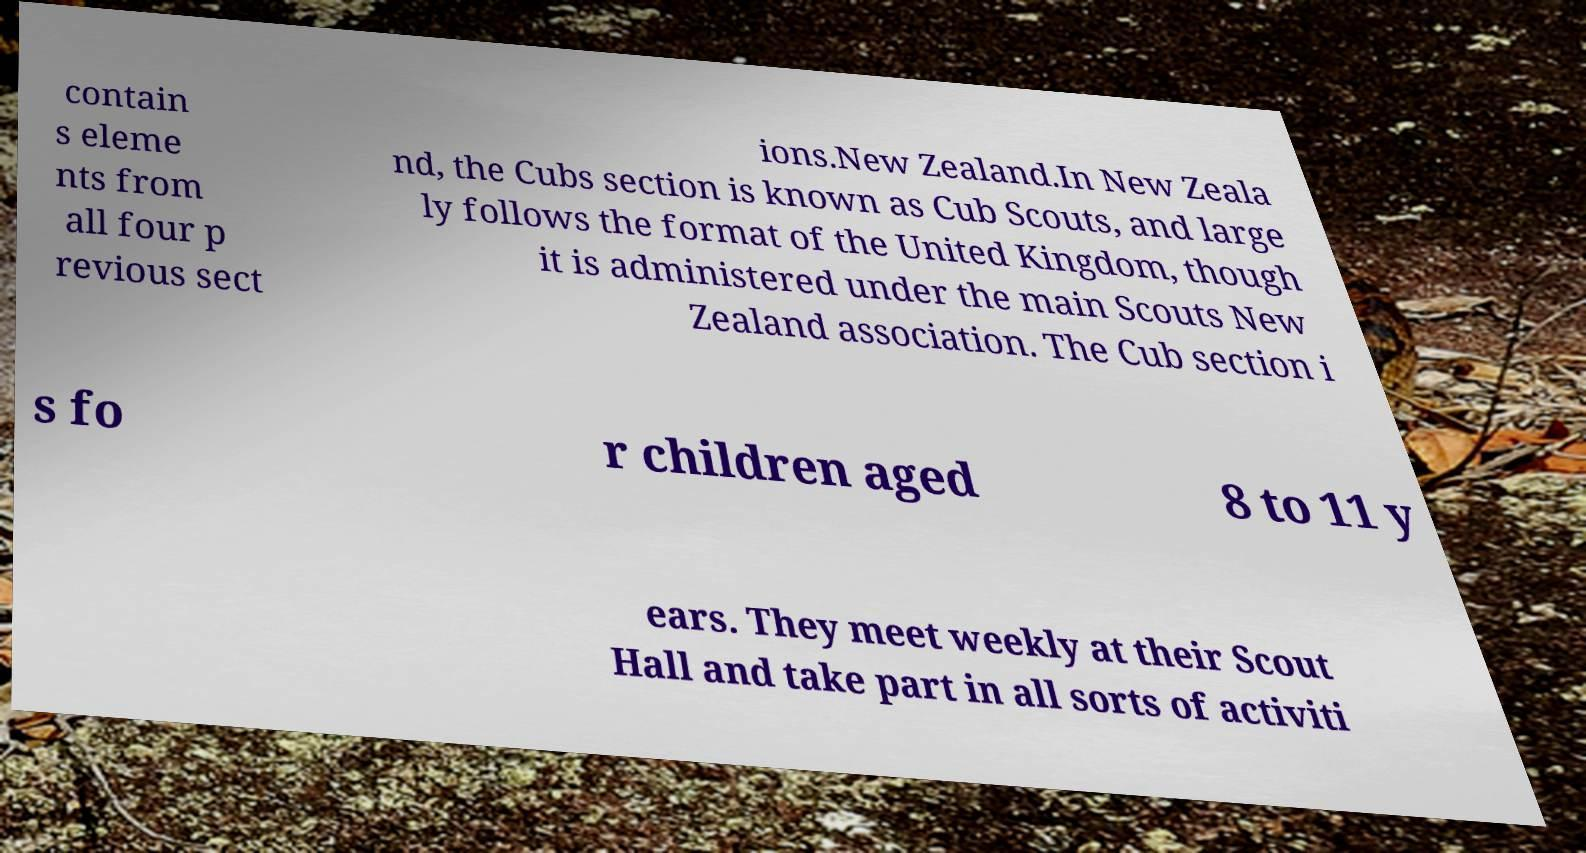Can you read and provide the text displayed in the image?This photo seems to have some interesting text. Can you extract and type it out for me? contain s eleme nts from all four p revious sect ions.New Zealand.In New Zeala nd, the Cubs section is known as Cub Scouts, and large ly follows the format of the United Kingdom, though it is administered under the main Scouts New Zealand association. The Cub section i s fo r children aged 8 to 11 y ears. They meet weekly at their Scout Hall and take part in all sorts of activiti 